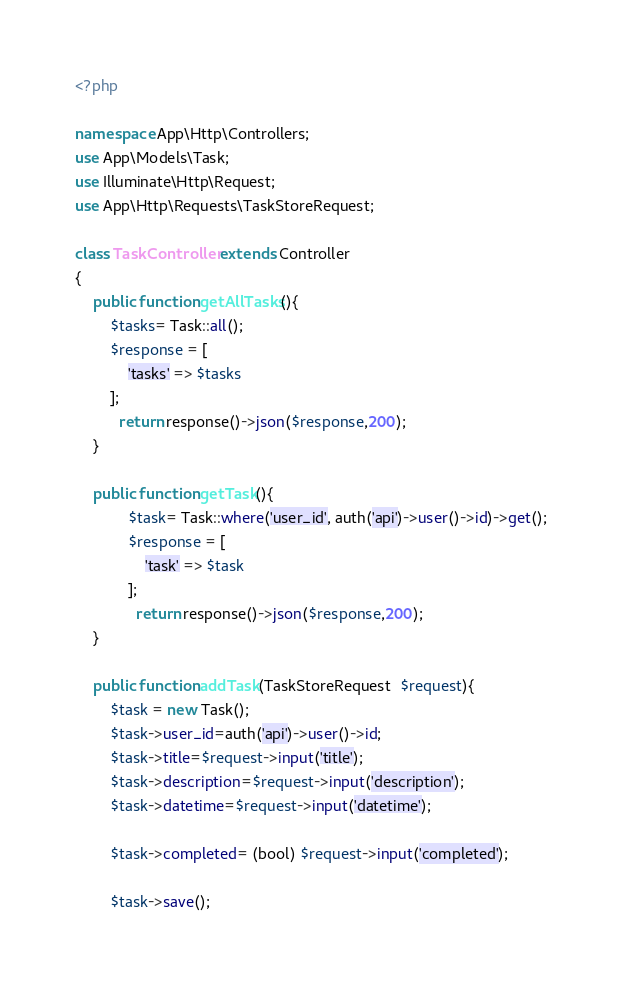Convert code to text. <code><loc_0><loc_0><loc_500><loc_500><_PHP_><?php

namespace App\Http\Controllers;
use App\Models\Task;
use Illuminate\Http\Request;
use App\Http\Requests\TaskStoreRequest;

class TaskController extends Controller
{
    public function getAllTasks(){
        $tasks= Task::all();
        $response = [
            'tasks' => $tasks
        ];
          return response()->json($response,200);
    }

    public function getTask(){
            $task= Task::where('user_id', auth('api')->user()->id)->get();
            $response = [
                'task' => $task
            ];
              return response()->json($response,200);
    }

    public function addTask(TaskStoreRequest  $request){
        $task = new Task();
        $task->user_id=auth('api')->user()->id;
        $task->title=$request->input('title');
        $task->description=$request->input('description');
        $task->datetime=$request->input('datetime');
     
        $task->completed= (bool) $request->input('completed');

        $task->save();</code> 